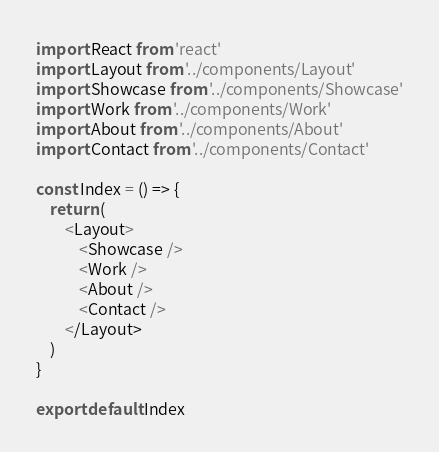Convert code to text. <code><loc_0><loc_0><loc_500><loc_500><_JavaScript_>import React from 'react'
import Layout from '../components/Layout'
import Showcase from '../components/Showcase'
import Work from '../components/Work'
import About from '../components/About'
import Contact from '../components/Contact'

const Index = () => {
    return (
        <Layout>
            <Showcase />
            <Work />
            <About />
            <Contact />
        </Layout>
    )
}

export default Index</code> 